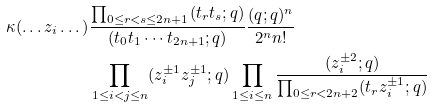<formula> <loc_0><loc_0><loc_500><loc_500>\kappa ( \dots z _ { i } \dots ) & \frac { \prod _ { 0 \leq r < s \leq 2 n + 1 } ( t _ { r } t _ { s } ; q ) } { ( t _ { 0 } t _ { 1 } \cdots t _ { 2 n + 1 } ; q ) } \frac { ( q ; q ) ^ { n } } { 2 ^ { n } n ! } \\ & \prod _ { 1 \leq i < j \leq n } ( z _ { i } ^ { \pm 1 } z _ { j } ^ { \pm 1 } ; q ) \prod _ { 1 \leq i \leq n } \frac { ( z _ { i } ^ { \pm 2 } ; q ) } { \prod _ { 0 \leq r < 2 n + 2 } ( t _ { r } z _ { i } ^ { \pm 1 } ; q ) }</formula> 